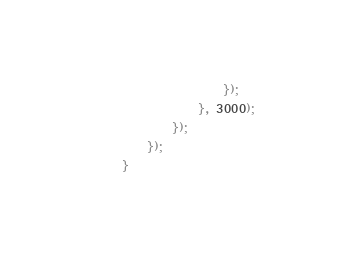<code> <loc_0><loc_0><loc_500><loc_500><_JavaScript_>				});
			}, 3000);
		});
	});
}</code> 